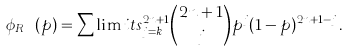Convert formula to latex. <formula><loc_0><loc_0><loc_500><loc_500>\phi _ { R _ { n k } } ( p ) = \sum \lim i t s _ { j = k } ^ { 2 n + 1 } { 2 n + 1 \choose j } p ^ { j } ( 1 - p ) ^ { 2 n + 1 - j } .</formula> 